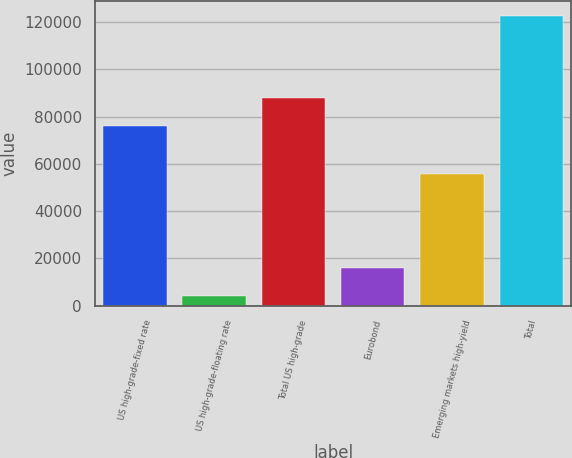Convert chart to OTSL. <chart><loc_0><loc_0><loc_500><loc_500><bar_chart><fcel>US high-grade-fixed rate<fcel>US high-grade-floating rate<fcel>Total US high-grade<fcel>Eurobond<fcel>Emerging markets high-yield<fcel>Total<nl><fcel>76060<fcel>4104<fcel>87924.6<fcel>15968.6<fcel>55904<fcel>122750<nl></chart> 